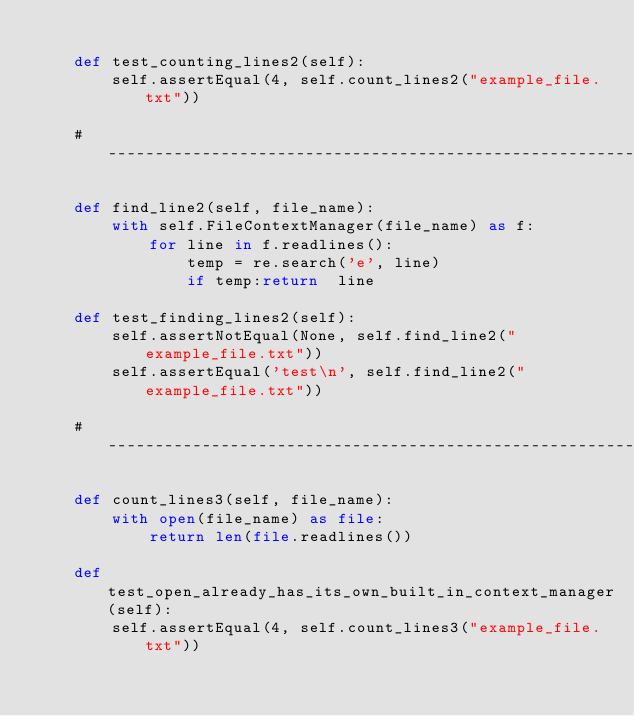<code> <loc_0><loc_0><loc_500><loc_500><_Python_>
    def test_counting_lines2(self):
        self.assertEqual(4, self.count_lines2("example_file.txt"))

    # ------------------------------------------------------------------

    def find_line2(self, file_name):
        with self.FileContextManager(file_name) as f:
            for line in f.readlines():
                temp = re.search('e', line)
                if temp:return  line

    def test_finding_lines2(self):
        self.assertNotEqual(None, self.find_line2("example_file.txt"))
        self.assertEqual('test\n', self.find_line2("example_file.txt"))

    # ------------------------------------------------------------------

    def count_lines3(self, file_name):
        with open(file_name) as file:
            return len(file.readlines())

    def test_open_already_has_its_own_built_in_context_manager(self):
        self.assertEqual(4, self.count_lines3("example_file.txt"))
</code> 